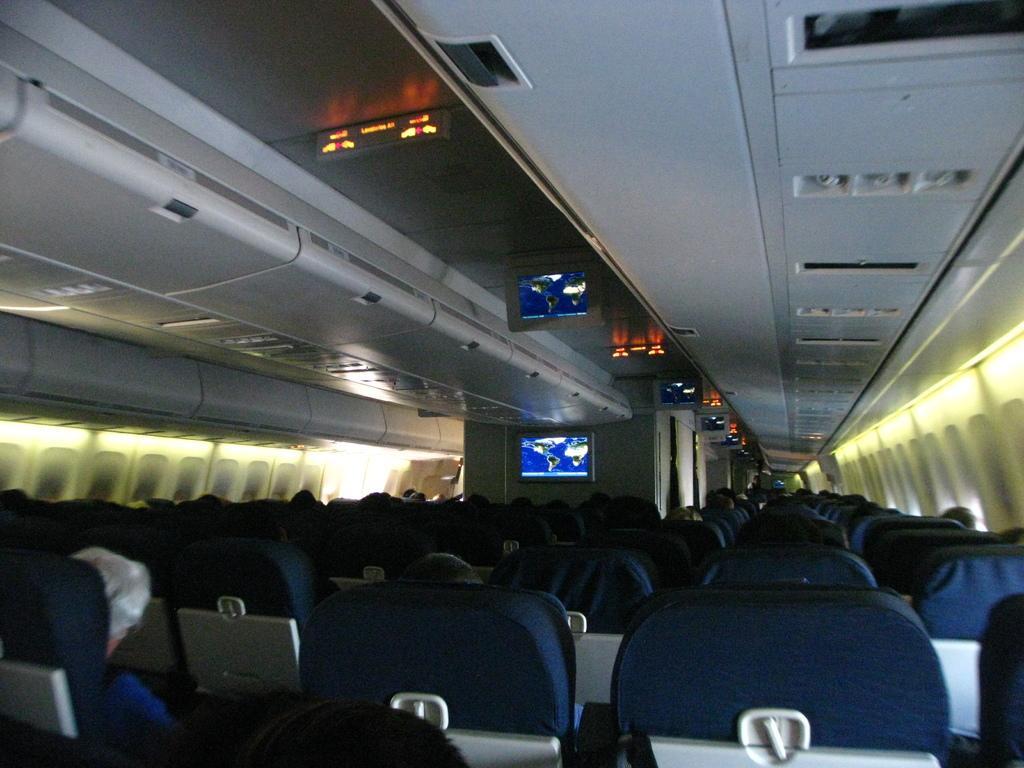Please provide a concise description of this image. In this image there are many chairs. People are sitting on the chairs. On the top screens are mounted. Here there is a screen. 